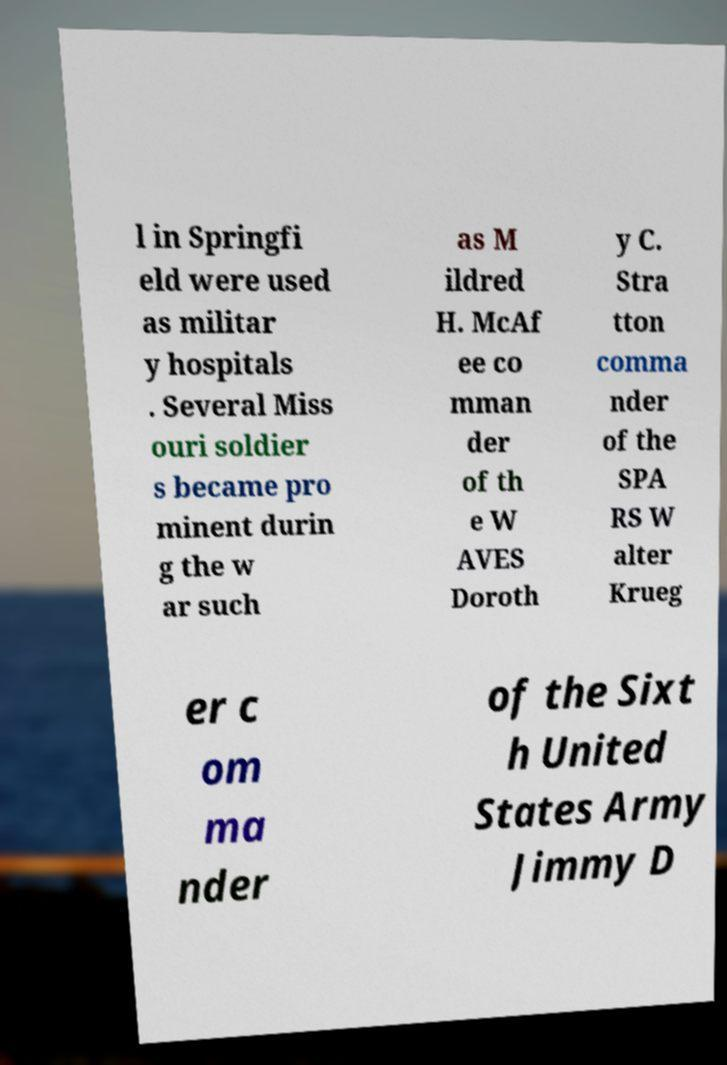I need the written content from this picture converted into text. Can you do that? l in Springfi eld were used as militar y hospitals . Several Miss ouri soldier s became pro minent durin g the w ar such as M ildred H. McAf ee co mman der of th e W AVES Doroth y C. Stra tton comma nder of the SPA RS W alter Krueg er c om ma nder of the Sixt h United States Army Jimmy D 